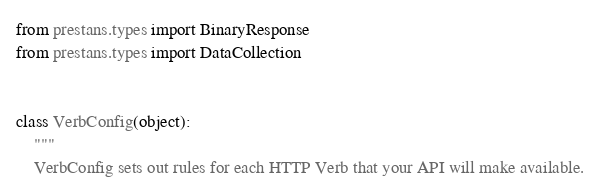<code> <loc_0><loc_0><loc_500><loc_500><_Python_>from prestans.types import BinaryResponse
from prestans.types import DataCollection


class VerbConfig(object):
    """
    VerbConfig sets out rules for each HTTP Verb that your API will make available.</code> 